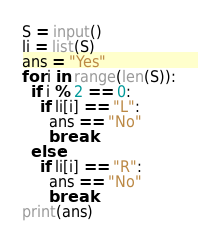<code> <loc_0><loc_0><loc_500><loc_500><_Python_>S = input()
li = list(S)
ans = "Yes"
for i in range(len(S)):
  if i % 2 == 0:
    if li[i] == "L":
      ans == "No"
      break
  else:
    if li[i] == "R":
      ans == "No"
      break
print(ans)</code> 